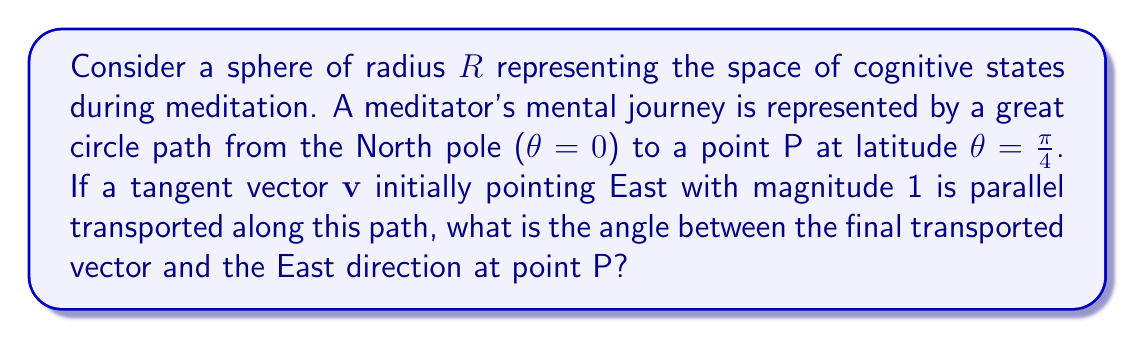Show me your answer to this math problem. Let's approach this step-by-step:

1) On a sphere, parallel transport along a great circle rotates the transported vector by an angle equal to the angle of rotation of the path itself.

2) The angle of rotation of the path is the same as the latitude change, which in this case is $\frac{\pi}{4}$.

3) The rotation of the vector is in the opposite direction to the path's rotation on the sphere's surface.

4) To calculate the final angle between the transported vector and the East direction, we need to consider the geometry of the sphere at point P:

   [asy]
   import three;
   size(200);
   currentprojection=perspective(6,3,2);
   
   draw(surface(sphere((0,0,0),1)),lightgrey);
   draw(Circle((0,0,0),1,Z),blue);
   dot((0,0,1),red);
   dot((1/sqrt(2),0,1/sqrt(2)),red);
   draw((0,0,1)--(1/sqrt(2),0,1/sqrt(2)),red);
   draw((-0.2,0.98,1/sqrt(2))--(0.2,0.98,1/sqrt(2)),green);
   draw((1/sqrt(2),-0.2,1/sqrt(2))--(1/sqrt(2),0.2,1/sqrt(2)),green);
   label("N",(0,0,1.1),N);
   label("P",(1/sqrt(2),0,1/sqrt(2)),E);
   label("v",(1/sqrt(2),0.25,1/sqrt(2)),N);
   [/asy]

5) At point P, the East direction is tangent to the latitude circle. The transported vector has rotated by $\frac{\pi}{4}$ towards the North pole.

6) The angle between these two vectors is therefore $\frac{\pi}{4}$.

This result is independent of the sphere's radius $R$, as parallel transport preserves angles.
Answer: $\frac{\pi}{4}$ radians 